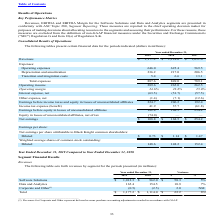According to Black Knight Financial Services's financial document, What was the revenue in 2019? According to the financial document, 1,177.2 (in millions). The relevant text states: "Revenues $ 1,177.2 $ 1,114.0 $ 1,051.6..." Also, What were the total expenses in 2018? According to the financial document, 849.0 (in millions). The relevant text states: "Total expenses 887.6 849.0 789.1..." Also, What was the net interest expense in 2017? According to the financial document, (57.5) (in millions). The relevant text states: "Interest expense, net (63.5) (51.7) (57.5)..." Also, can you calculate: What was the change in operating income between 2017 and 2018? Based on the calculation: 265.0-262.5, the result is 2.5 (in millions). This is based on the information: "Operating income 289.6 265.0 262.5 Operating income 289.6 265.0 262.5..." The key data points involved are: 262.5, 265.0. Also, How many years did the operating margin exceed 20.0%? Counting the relevant items in the document: 2019, 2018, 2017, I find 3 instances. The key data points involved are: 2017, 2018, 2019. Also, can you calculate: What was the change in net earnings between 2018 and 2019? To answer this question, I need to perform calculations using the financial data. The calculation is: (108.8-168.5)/168.5, which equals -35.43 (percentage). This is based on the information: "uity in losses of unconsolidated affiliates 182.8 168.5 254.2 Net earnings $ 108.8 $ 168.5 $ 254.2..." The key data points involved are: 108.8, 168.5. 